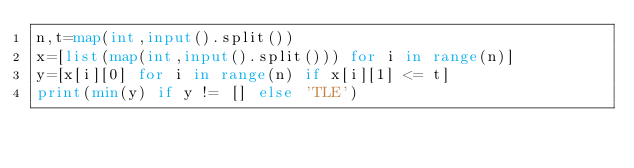Convert code to text. <code><loc_0><loc_0><loc_500><loc_500><_Python_>n,t=map(int,input().split())
x=[list(map(int,input().split())) for i in range(n)]
y=[x[i][0] for i in range(n) if x[i][1] <= t]
print(min(y) if y != [] else 'TLE')
</code> 